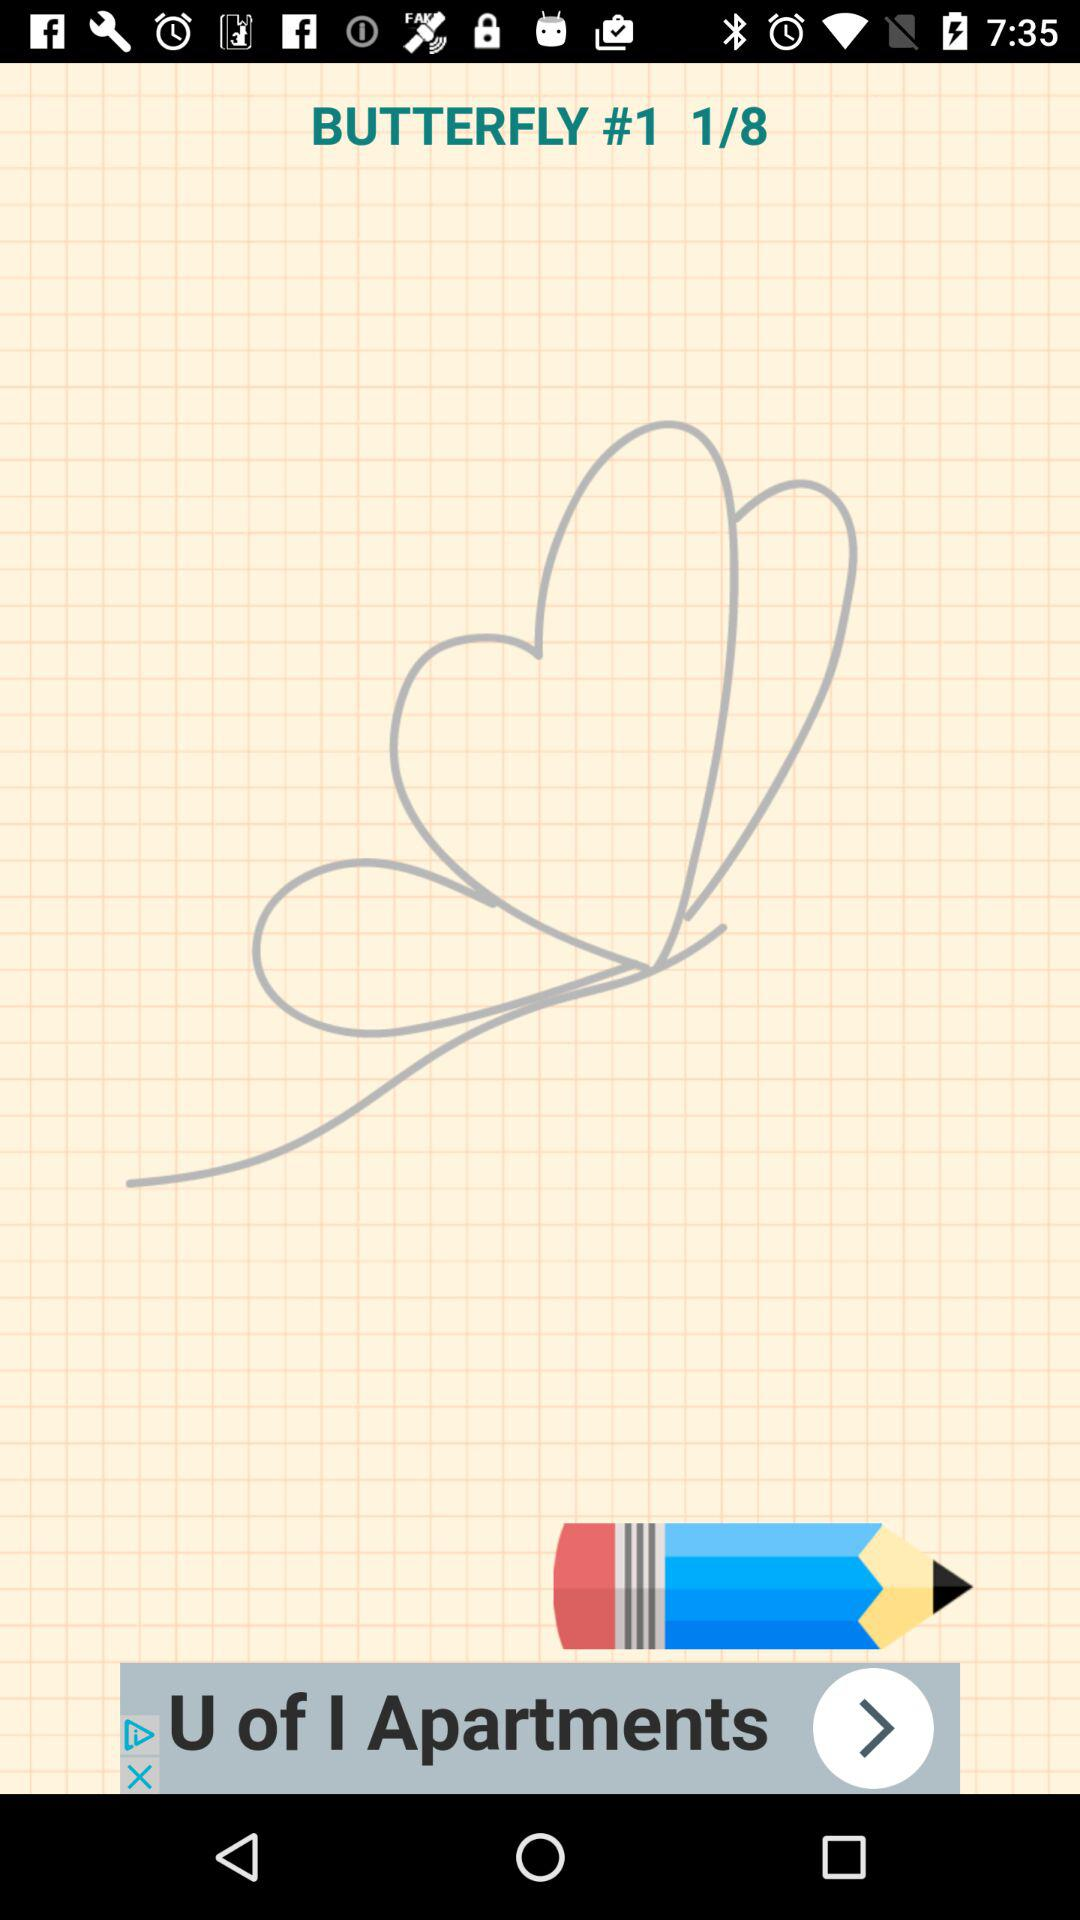At which page am I? You are at the first page. 